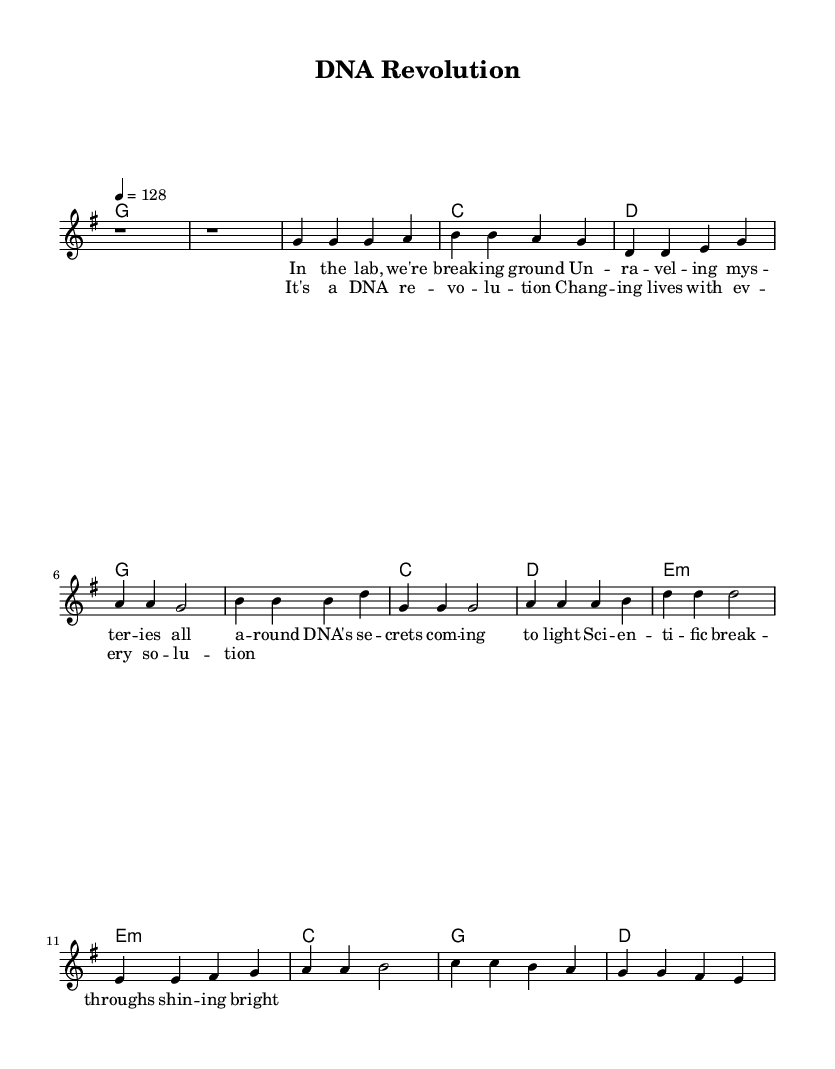What is the key signature of this music? The key signature is G major, which has one sharp (F#). This is evident from the global settings where it mentions \key g \major.
Answer: G major What is the time signature of this music? The time signature is 4/4, indicating four beats per measure and that each quarter note gets one beat. This information is found in the global settings with \time 4/4.
Answer: 4/4 What is the tempo marking for this piece? The tempo marking is 128 beats per minute, as indicated by the tempo directive 4 = 128 in the global settings. This shows how fast the piece should be played.
Answer: 128 How many measures are in the verse? The verse consists of four measures as seen in the melody line, where the notes g, a, b, d, e, and g are structured over four beats.
Answer: Four measures Which chord is used during the chorus? The chords used in the chorus are G, C, D, and E minor. This is drawn from the harmonies section where the chord progression for the chorus is provided.
Answer: G, C, D, E minor What thematic element is prominent in the lyrics? The thematic element is scientific breakthroughs and discoveries, evident from the lyrics discussing the unveiling of DNA secrets and scientific advancements. This aligns with the title "DNA Revolution," which supports the focus on science.
Answer: Scientific breakthroughs What type of song structure does this piece utilize? This piece utilizes a structure typical of a verse-chorus format, as seen in the alternation between the verse and chorus sections indicated in the melody and lyrics. This is common in country rock music as it provides a catchy and repetitive musical framework.
Answer: Verse-chorus structure 